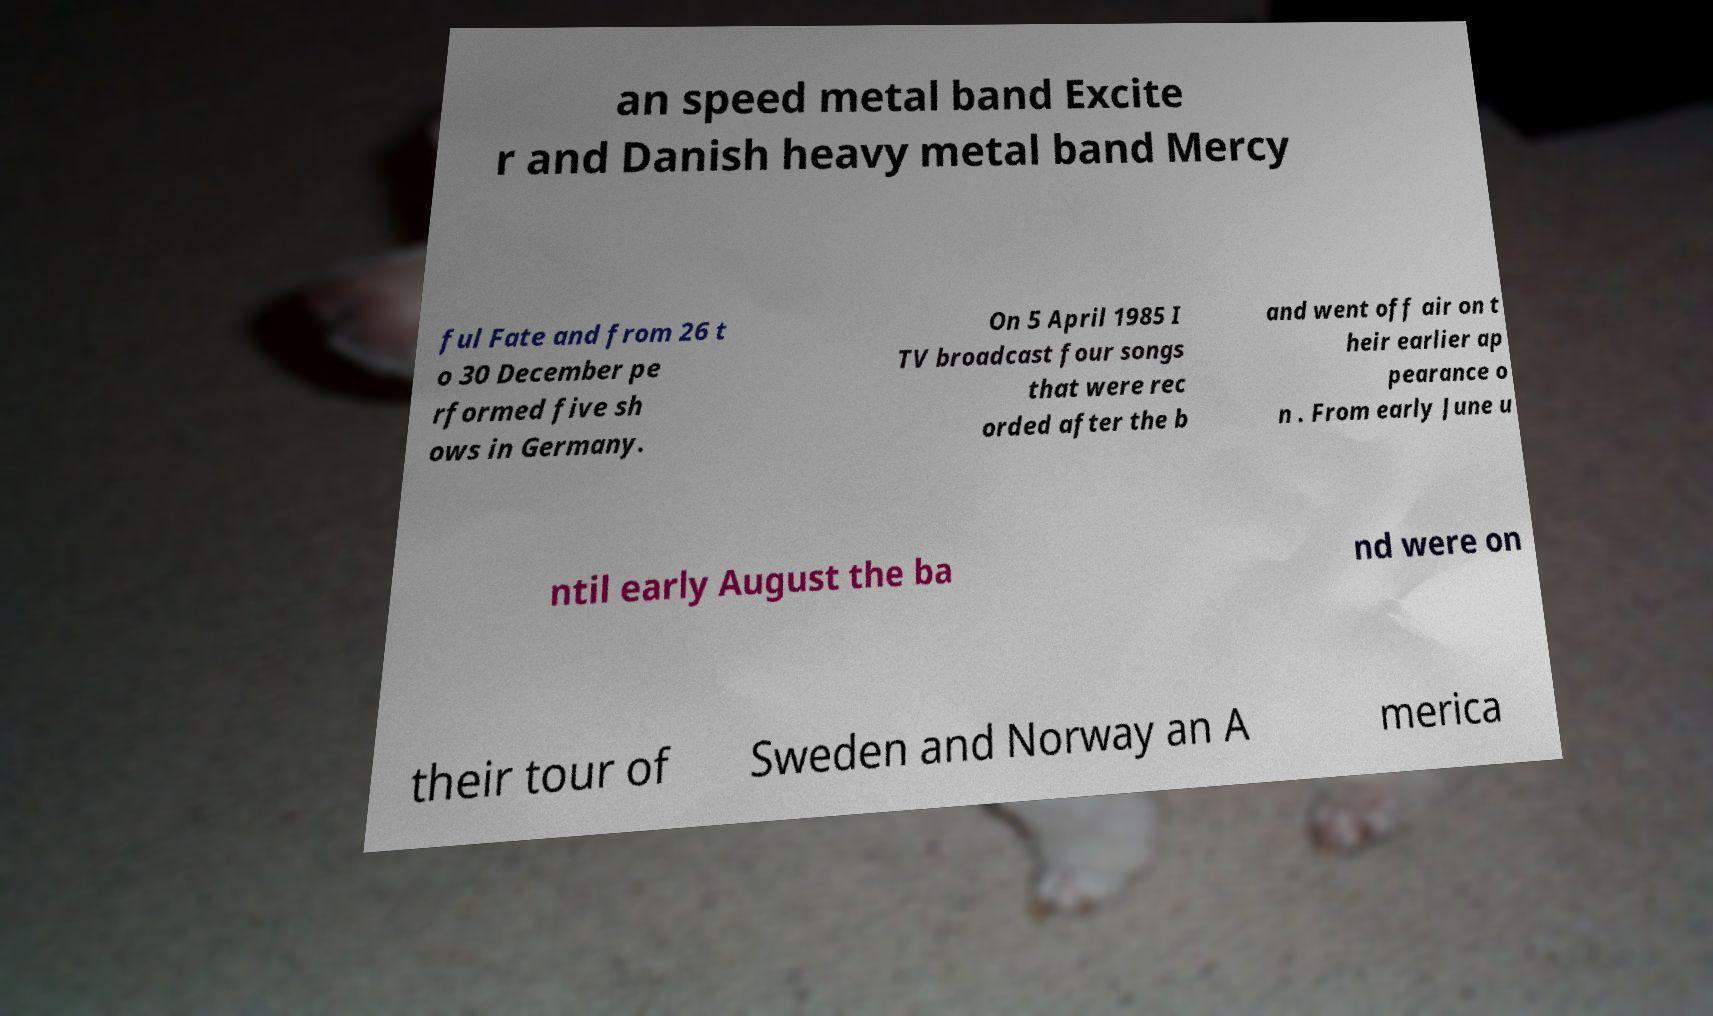Could you extract and type out the text from this image? an speed metal band Excite r and Danish heavy metal band Mercy ful Fate and from 26 t o 30 December pe rformed five sh ows in Germany. On 5 April 1985 I TV broadcast four songs that were rec orded after the b and went off air on t heir earlier ap pearance o n . From early June u ntil early August the ba nd were on their tour of Sweden and Norway an A merica 